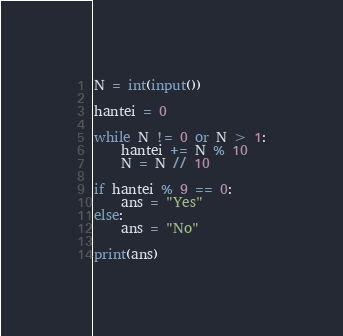<code> <loc_0><loc_0><loc_500><loc_500><_Python_>N = int(input())

hantei = 0

while N != 0 or N > 1:
    hantei += N % 10
    N = N // 10

if hantei % 9 == 0:
    ans = "Yes"
else:
    ans = "No"

print(ans)
</code> 